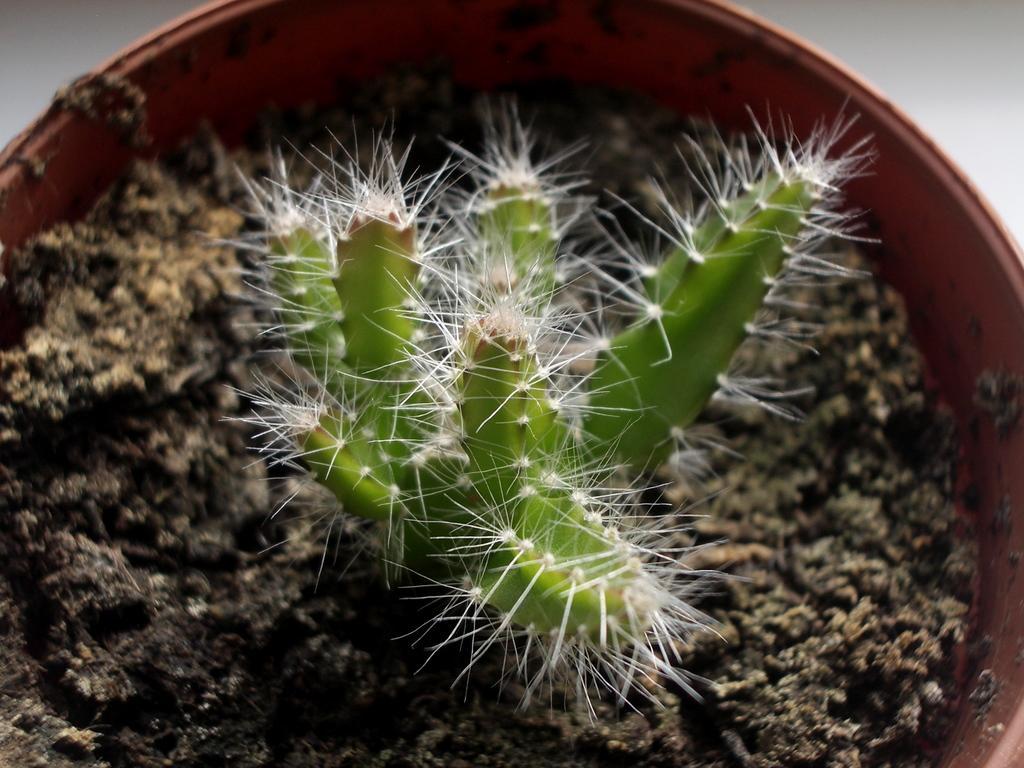Please provide a concise description of this image. In this picture we can see green color cactus plant with white thorns, seen in the small pot. 